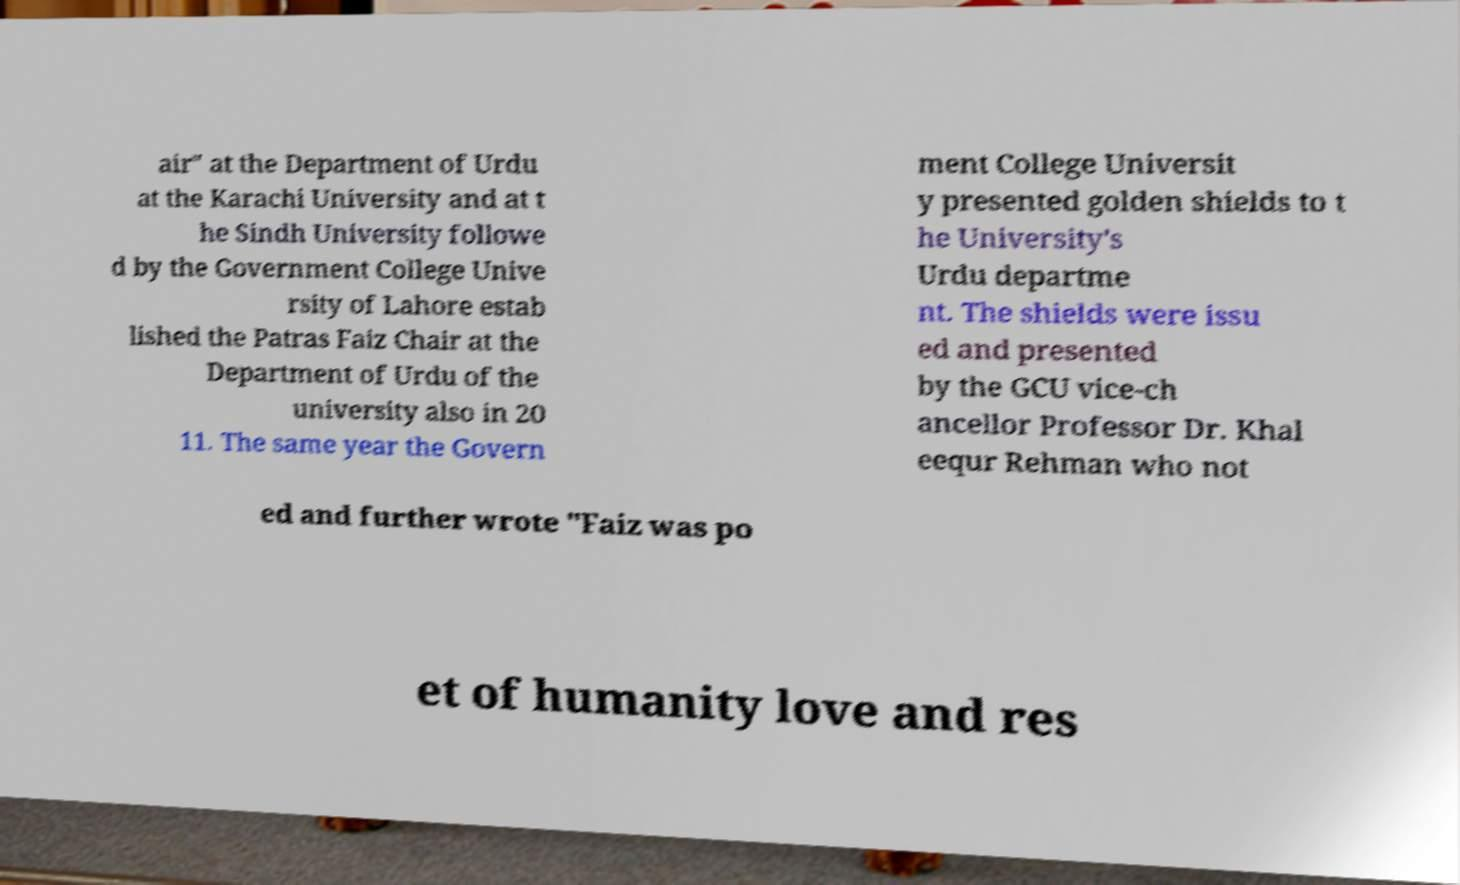Could you extract and type out the text from this image? air" at the Department of Urdu at the Karachi University and at t he Sindh University followe d by the Government College Unive rsity of Lahore estab lished the Patras Faiz Chair at the Department of Urdu of the university also in 20 11. The same year the Govern ment College Universit y presented golden shields to t he University's Urdu departme nt. The shields were issu ed and presented by the GCU vice-ch ancellor Professor Dr. Khal eequr Rehman who not ed and further wrote "Faiz was po et of humanity love and res 